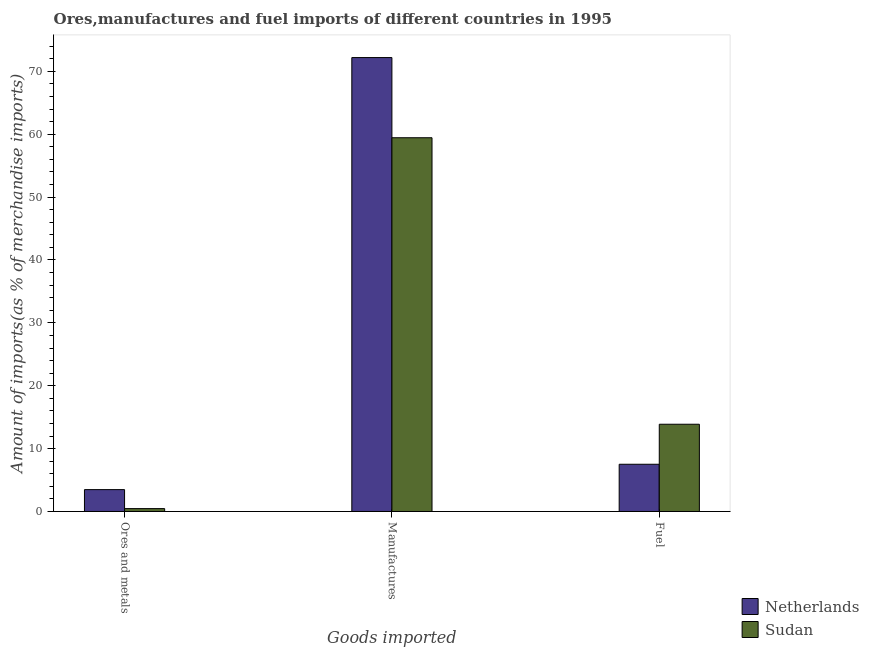How many groups of bars are there?
Make the answer very short. 3. Are the number of bars per tick equal to the number of legend labels?
Keep it short and to the point. Yes. How many bars are there on the 1st tick from the left?
Provide a short and direct response. 2. How many bars are there on the 1st tick from the right?
Offer a terse response. 2. What is the label of the 1st group of bars from the left?
Provide a short and direct response. Ores and metals. What is the percentage of manufactures imports in Sudan?
Offer a very short reply. 59.44. Across all countries, what is the maximum percentage of manufactures imports?
Keep it short and to the point. 72.19. Across all countries, what is the minimum percentage of manufactures imports?
Your answer should be very brief. 59.44. In which country was the percentage of fuel imports maximum?
Your answer should be very brief. Sudan. In which country was the percentage of fuel imports minimum?
Provide a short and direct response. Netherlands. What is the total percentage of ores and metals imports in the graph?
Provide a succinct answer. 3.94. What is the difference between the percentage of fuel imports in Netherlands and that in Sudan?
Your answer should be compact. -6.36. What is the difference between the percentage of manufactures imports in Sudan and the percentage of ores and metals imports in Netherlands?
Offer a very short reply. 55.96. What is the average percentage of fuel imports per country?
Your response must be concise. 10.69. What is the difference between the percentage of fuel imports and percentage of manufactures imports in Netherlands?
Give a very brief answer. -64.68. In how many countries, is the percentage of fuel imports greater than 28 %?
Your answer should be very brief. 0. What is the ratio of the percentage of manufactures imports in Netherlands to that in Sudan?
Your answer should be compact. 1.21. Is the percentage of manufactures imports in Netherlands less than that in Sudan?
Your response must be concise. No. What is the difference between the highest and the second highest percentage of ores and metals imports?
Provide a succinct answer. 3.02. What is the difference between the highest and the lowest percentage of manufactures imports?
Provide a succinct answer. 12.75. What does the 2nd bar from the left in Manufactures represents?
Offer a very short reply. Sudan. What does the 1st bar from the right in Fuel represents?
Give a very brief answer. Sudan. How many bars are there?
Your answer should be compact. 6. How many countries are there in the graph?
Your response must be concise. 2. What is the difference between two consecutive major ticks on the Y-axis?
Provide a short and direct response. 10. Does the graph contain any zero values?
Offer a terse response. No. What is the title of the graph?
Your response must be concise. Ores,manufactures and fuel imports of different countries in 1995. Does "Tunisia" appear as one of the legend labels in the graph?
Keep it short and to the point. No. What is the label or title of the X-axis?
Your answer should be compact. Goods imported. What is the label or title of the Y-axis?
Your answer should be compact. Amount of imports(as % of merchandise imports). What is the Amount of imports(as % of merchandise imports) in Netherlands in Ores and metals?
Your answer should be compact. 3.48. What is the Amount of imports(as % of merchandise imports) of Sudan in Ores and metals?
Give a very brief answer. 0.46. What is the Amount of imports(as % of merchandise imports) of Netherlands in Manufactures?
Your answer should be compact. 72.19. What is the Amount of imports(as % of merchandise imports) of Sudan in Manufactures?
Offer a terse response. 59.44. What is the Amount of imports(as % of merchandise imports) in Netherlands in Fuel?
Keep it short and to the point. 7.51. What is the Amount of imports(as % of merchandise imports) of Sudan in Fuel?
Provide a short and direct response. 13.87. Across all Goods imported, what is the maximum Amount of imports(as % of merchandise imports) of Netherlands?
Keep it short and to the point. 72.19. Across all Goods imported, what is the maximum Amount of imports(as % of merchandise imports) of Sudan?
Provide a short and direct response. 59.44. Across all Goods imported, what is the minimum Amount of imports(as % of merchandise imports) of Netherlands?
Offer a very short reply. 3.48. Across all Goods imported, what is the minimum Amount of imports(as % of merchandise imports) in Sudan?
Your answer should be compact. 0.46. What is the total Amount of imports(as % of merchandise imports) of Netherlands in the graph?
Keep it short and to the point. 83.18. What is the total Amount of imports(as % of merchandise imports) of Sudan in the graph?
Your answer should be compact. 73.77. What is the difference between the Amount of imports(as % of merchandise imports) of Netherlands in Ores and metals and that in Manufactures?
Provide a short and direct response. -68.71. What is the difference between the Amount of imports(as % of merchandise imports) of Sudan in Ores and metals and that in Manufactures?
Your answer should be compact. -58.98. What is the difference between the Amount of imports(as % of merchandise imports) of Netherlands in Ores and metals and that in Fuel?
Offer a terse response. -4.03. What is the difference between the Amount of imports(as % of merchandise imports) in Sudan in Ores and metals and that in Fuel?
Make the answer very short. -13.42. What is the difference between the Amount of imports(as % of merchandise imports) of Netherlands in Manufactures and that in Fuel?
Keep it short and to the point. 64.68. What is the difference between the Amount of imports(as % of merchandise imports) in Sudan in Manufactures and that in Fuel?
Ensure brevity in your answer.  45.56. What is the difference between the Amount of imports(as % of merchandise imports) of Netherlands in Ores and metals and the Amount of imports(as % of merchandise imports) of Sudan in Manufactures?
Provide a short and direct response. -55.96. What is the difference between the Amount of imports(as % of merchandise imports) of Netherlands in Ores and metals and the Amount of imports(as % of merchandise imports) of Sudan in Fuel?
Give a very brief answer. -10.4. What is the difference between the Amount of imports(as % of merchandise imports) in Netherlands in Manufactures and the Amount of imports(as % of merchandise imports) in Sudan in Fuel?
Give a very brief answer. 58.32. What is the average Amount of imports(as % of merchandise imports) of Netherlands per Goods imported?
Provide a short and direct response. 27.73. What is the average Amount of imports(as % of merchandise imports) in Sudan per Goods imported?
Keep it short and to the point. 24.59. What is the difference between the Amount of imports(as % of merchandise imports) of Netherlands and Amount of imports(as % of merchandise imports) of Sudan in Ores and metals?
Give a very brief answer. 3.02. What is the difference between the Amount of imports(as % of merchandise imports) of Netherlands and Amount of imports(as % of merchandise imports) of Sudan in Manufactures?
Provide a short and direct response. 12.75. What is the difference between the Amount of imports(as % of merchandise imports) in Netherlands and Amount of imports(as % of merchandise imports) in Sudan in Fuel?
Offer a terse response. -6.36. What is the ratio of the Amount of imports(as % of merchandise imports) in Netherlands in Ores and metals to that in Manufactures?
Offer a very short reply. 0.05. What is the ratio of the Amount of imports(as % of merchandise imports) in Sudan in Ores and metals to that in Manufactures?
Your answer should be compact. 0.01. What is the ratio of the Amount of imports(as % of merchandise imports) of Netherlands in Ores and metals to that in Fuel?
Your response must be concise. 0.46. What is the ratio of the Amount of imports(as % of merchandise imports) of Sudan in Ores and metals to that in Fuel?
Provide a short and direct response. 0.03. What is the ratio of the Amount of imports(as % of merchandise imports) in Netherlands in Manufactures to that in Fuel?
Your answer should be very brief. 9.61. What is the ratio of the Amount of imports(as % of merchandise imports) of Sudan in Manufactures to that in Fuel?
Offer a terse response. 4.28. What is the difference between the highest and the second highest Amount of imports(as % of merchandise imports) of Netherlands?
Make the answer very short. 64.68. What is the difference between the highest and the second highest Amount of imports(as % of merchandise imports) of Sudan?
Your answer should be compact. 45.56. What is the difference between the highest and the lowest Amount of imports(as % of merchandise imports) of Netherlands?
Give a very brief answer. 68.71. What is the difference between the highest and the lowest Amount of imports(as % of merchandise imports) in Sudan?
Give a very brief answer. 58.98. 